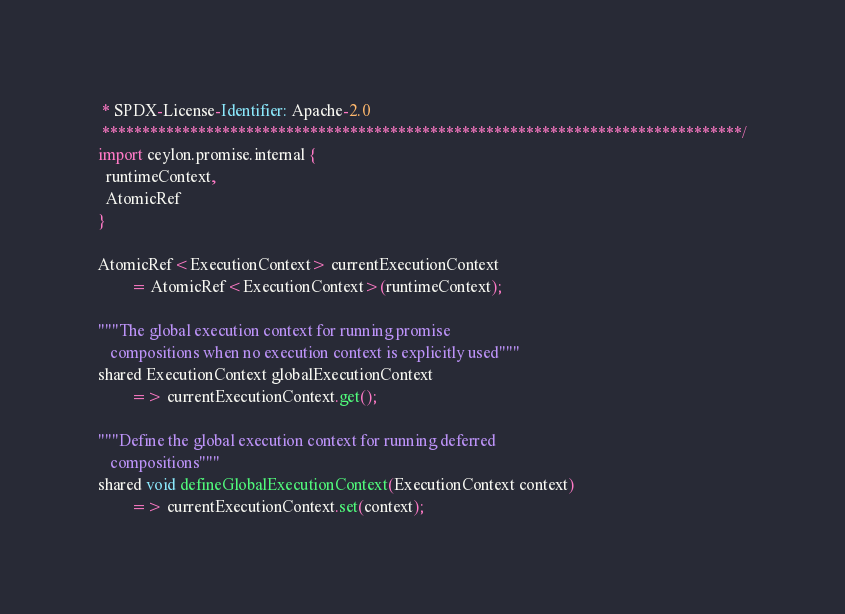Convert code to text. <code><loc_0><loc_0><loc_500><loc_500><_Ceylon_> * SPDX-License-Identifier: Apache-2.0 
 ********************************************************************************/
import ceylon.promise.internal {
  runtimeContext,
  AtomicRef
}

AtomicRef<ExecutionContext> currentExecutionContext 
        = AtomicRef<ExecutionContext>(runtimeContext);

"""The global execution context for running promise 
   compositions when no execution context is explicitly used"""
shared ExecutionContext globalExecutionContext 
        => currentExecutionContext.get();

"""Define the global execution context for running deferred 
   compositions"""
shared void defineGlobalExecutionContext(ExecutionContext context) 
        => currentExecutionContext.set(context);
</code> 